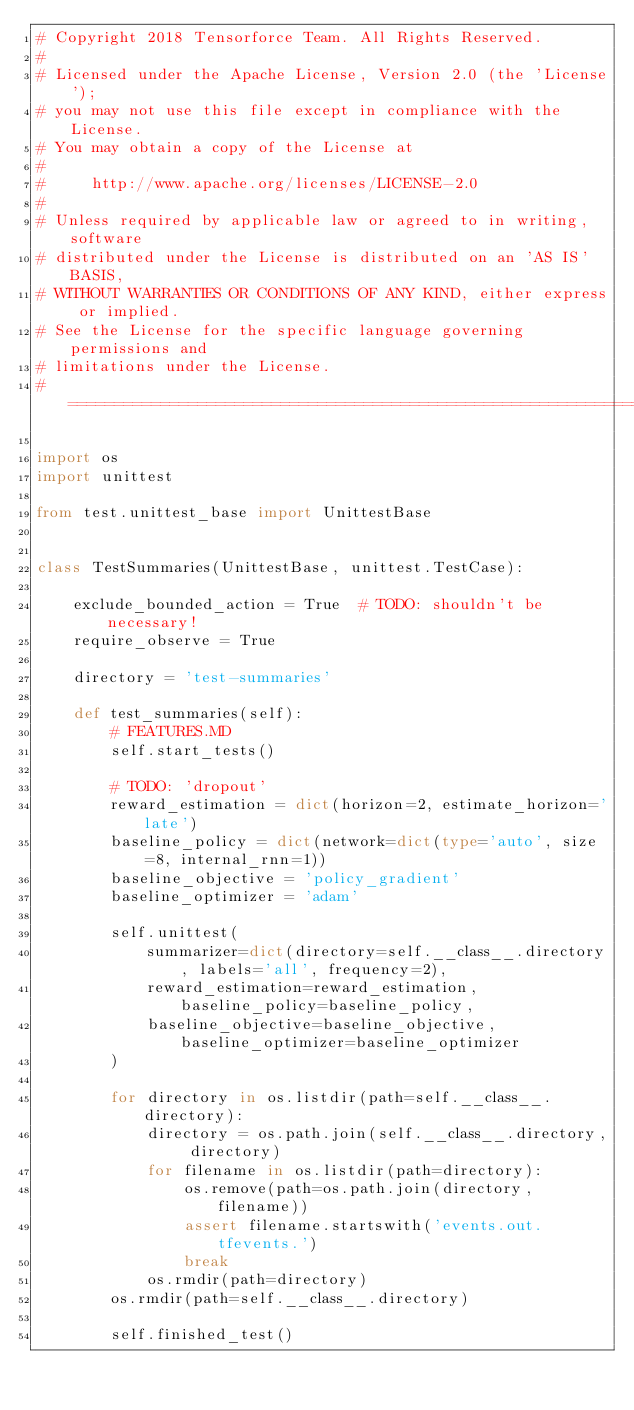Convert code to text. <code><loc_0><loc_0><loc_500><loc_500><_Python_># Copyright 2018 Tensorforce Team. All Rights Reserved.
#
# Licensed under the Apache License, Version 2.0 (the 'License');
# you may not use this file except in compliance with the License.
# You may obtain a copy of the License at
#
#     http://www.apache.org/licenses/LICENSE-2.0
#
# Unless required by applicable law or agreed to in writing, software
# distributed under the License is distributed on an 'AS IS' BASIS,
# WITHOUT WARRANTIES OR CONDITIONS OF ANY KIND, either express or implied.
# See the License for the specific language governing permissions and
# limitations under the License.
# ==============================================================================

import os
import unittest

from test.unittest_base import UnittestBase


class TestSummaries(UnittestBase, unittest.TestCase):

    exclude_bounded_action = True  # TODO: shouldn't be necessary!
    require_observe = True

    directory = 'test-summaries'

    def test_summaries(self):
        # FEATURES.MD
        self.start_tests()

        # TODO: 'dropout'
        reward_estimation = dict(horizon=2, estimate_horizon='late')
        baseline_policy = dict(network=dict(type='auto', size=8, internal_rnn=1))
        baseline_objective = 'policy_gradient'
        baseline_optimizer = 'adam'

        self.unittest(
            summarizer=dict(directory=self.__class__.directory, labels='all', frequency=2),
            reward_estimation=reward_estimation, baseline_policy=baseline_policy,
            baseline_objective=baseline_objective, baseline_optimizer=baseline_optimizer
        )

        for directory in os.listdir(path=self.__class__.directory):
            directory = os.path.join(self.__class__.directory, directory)
            for filename in os.listdir(path=directory):
                os.remove(path=os.path.join(directory, filename))
                assert filename.startswith('events.out.tfevents.')
                break
            os.rmdir(path=directory)
        os.rmdir(path=self.__class__.directory)

        self.finished_test()
</code> 